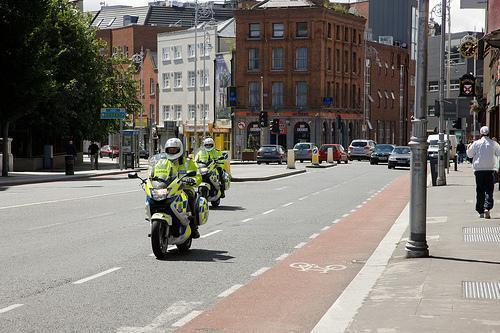How many motorcycles are on the road?
Give a very brief answer. 2. 